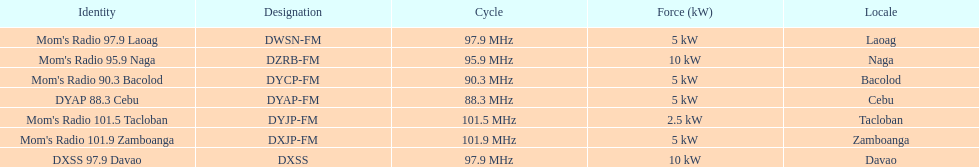How many kw was the radio in davao? 10 kW. Could you parse the entire table as a dict? {'header': ['Identity', 'Designation', 'Cycle', 'Force (kW)', 'Locale'], 'rows': [["Mom's Radio 97.9 Laoag", 'DWSN-FM', '97.9\xa0MHz', '5\xa0kW', 'Laoag'], ["Mom's Radio 95.9 Naga", 'DZRB-FM', '95.9\xa0MHz', '10\xa0kW', 'Naga'], ["Mom's Radio 90.3 Bacolod", 'DYCP-FM', '90.3\xa0MHz', '5\xa0kW', 'Bacolod'], ['DYAP 88.3 Cebu', 'DYAP-FM', '88.3\xa0MHz', '5\xa0kW', 'Cebu'], ["Mom's Radio 101.5 Tacloban", 'DYJP-FM', '101.5\xa0MHz', '2.5\xa0kW', 'Tacloban'], ["Mom's Radio 101.9 Zamboanga", 'DXJP-FM', '101.9\xa0MHz', '5\xa0kW', 'Zamboanga'], ['DXSS 97.9 Davao', 'DXSS', '97.9\xa0MHz', '10\xa0kW', 'Davao']]} 